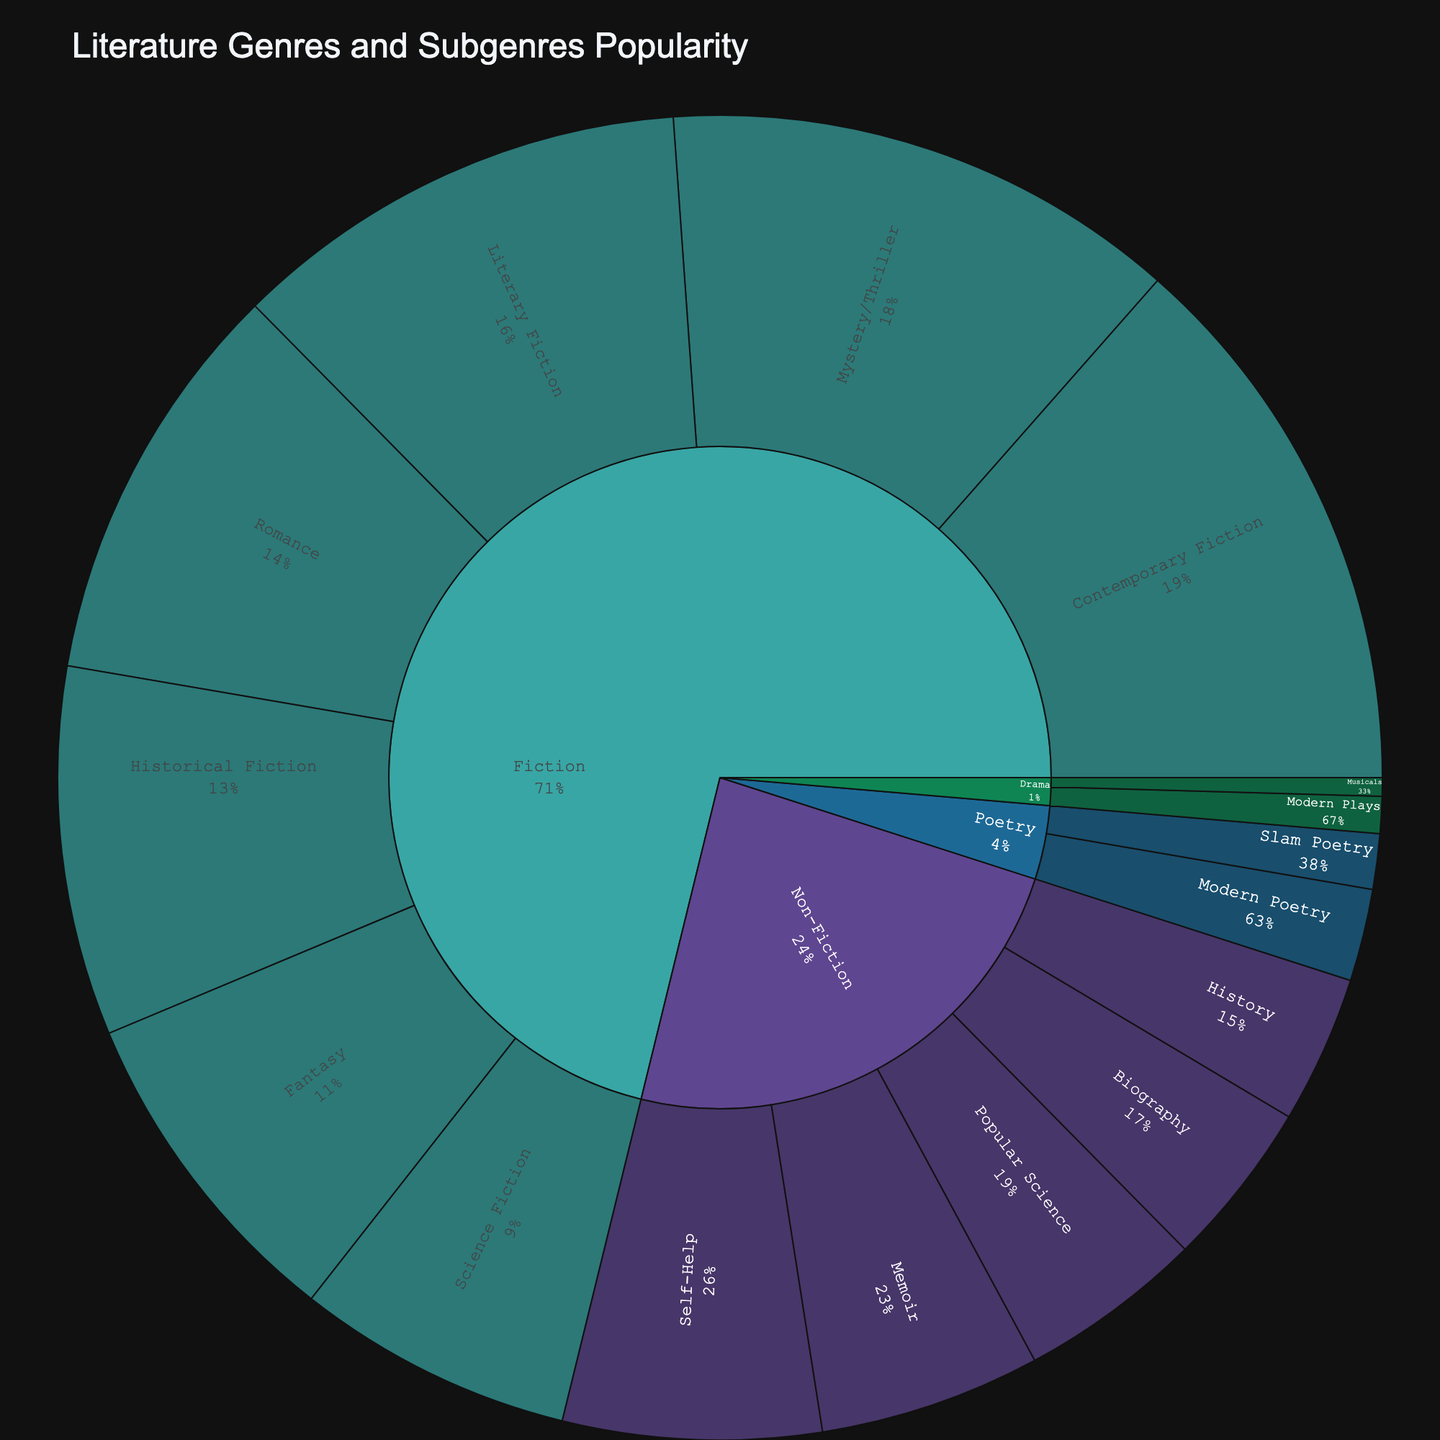What is the most popular genre? To find the most popular genre, look at the largest segment among all genres in the sunburst plot. Fiction holds the largest share among genres in the plot.
Answer: Fiction Which subgenre within Fiction has the highest popularity? Within the Fiction segment, observe the relative sizes of the subgenre segments to determine which one is the largest. Contemporary Fiction has the largest segment.
Answer: Contemporary Fiction What is the total popularity of all Non-Fiction subgenres combined? Sum up the popularity values of all Non-Fiction subgenres: Memoir (12), Self-Help (14), Popular Science (10), History (8), and Biography (9). Total = 12 + 14 + 10 + 8 + 9 = 53.
Answer: 53 How does the popularity of Historical Fiction compare to Modern Poetry? Compare the popularity values directly: Historical Fiction has a popularity of 20, while Modern Poetry has a popularity of 5. Historical Fiction is more popular.
Answer: Historical Fiction What percentage of the overall popularity does Romance within Fiction represent? First, find the total popularity value by summing up all the values. Total = 25 (Literary Fiction) + 30 (Contemporary Fiction) + 20 (Historical Fiction) + 15 (Science Fiction) + 18 (Fantasy) + 28 (Mystery/Thriller) + 22 (Romance) + 12 (Memoir) + 14 (Self-Help) + 10 (Popular Science) + 8 (History) + 9 (Biography) + 5 (Modern Poetry) + 3 (Slam Poetry) + 2 (Modern Plays) + 1 (Musicals) = 222. Now, calculate the percentage for Romance: (22/222) * 100 ≈ 9.91%.
Answer: 9.91% Which genre has the least popular subgenre and what is its popularity? Look for the smallest segment representing a subgenre. The smallest subgenre segment is Musicals within Drama with a popularity of 1.
Answer: Drama, 1 How many subgenres does Non-Fiction have? Count the number of subgenre segments within the Non-Fiction genre segment: Memoir, Self-Help, Popular Science, History, and Biography. There are 5 subgenres.
Answer: 5 What is the combined popularity of Memoir and Self-Help? Add the popularity values of Memoir (12) and Self-Help (14). Combined popularity is 12 + 14 = 26.
Answer: 26 Is Fantasy more popular than Science Fiction? Compare the popularity values of Fantasy (18) and Science Fiction (15). Fantasy is more popular than Science Fiction.
Answer: Yes 